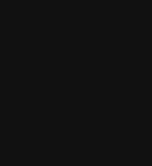<code> <loc_0><loc_0><loc_500><loc_500><_SQL_>
</code> 